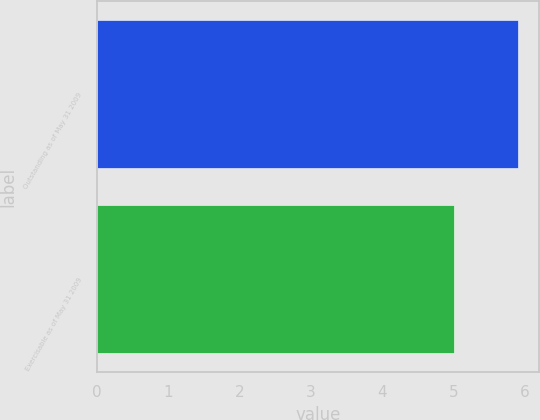<chart> <loc_0><loc_0><loc_500><loc_500><bar_chart><fcel>Outstanding as of May 31 2009<fcel>Exercisable as of May 31 2009<nl><fcel>5.9<fcel>5<nl></chart> 